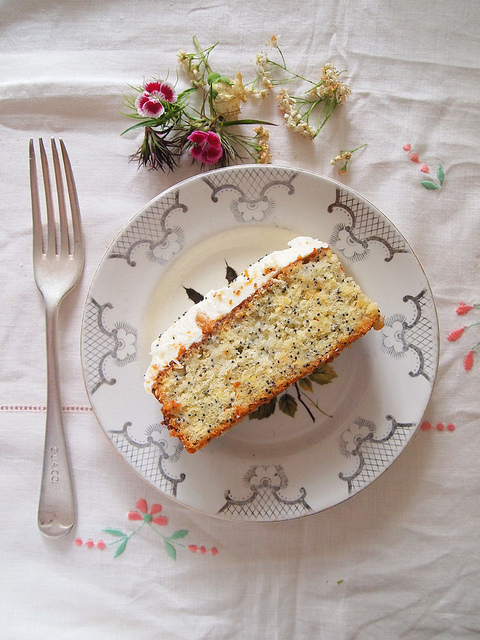If the cake could speak, what story would it tell? If the cake could speak, it would unfold a tale of meticulous preparation and joyful anticipation. It would reminisce about the gentle hands that whipped up its batter, the laughter filling the kitchen as the aroma of baking enveloped the room. The cake would express its excitement in being adorned with a creamy layer of frosting, feeling like it was being dressed for a momentous occasion. It would beam with pride as it takes center stage on the decorated plate, surrounded by the vibrant flowers. Conceived for an upcoming celebration, the cake would eagerly anticipate the moment it’s shared among loved ones, becoming a part of their cherished memories and festivities. 